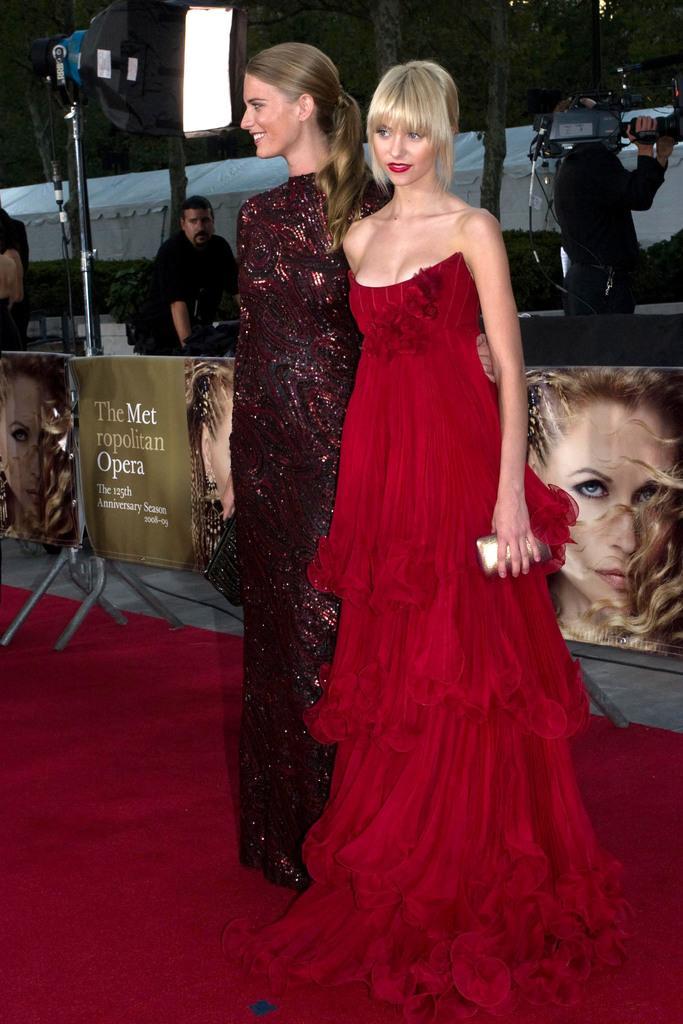How would you summarize this image in a sentence or two? In this image I can see a woman wearing red colored dress and another woman wearing pink and black colored dress are standing on the red carpet and smiling. In the background I can see few banners, few persons standing, a person standing and holding a camera and few other objects. 